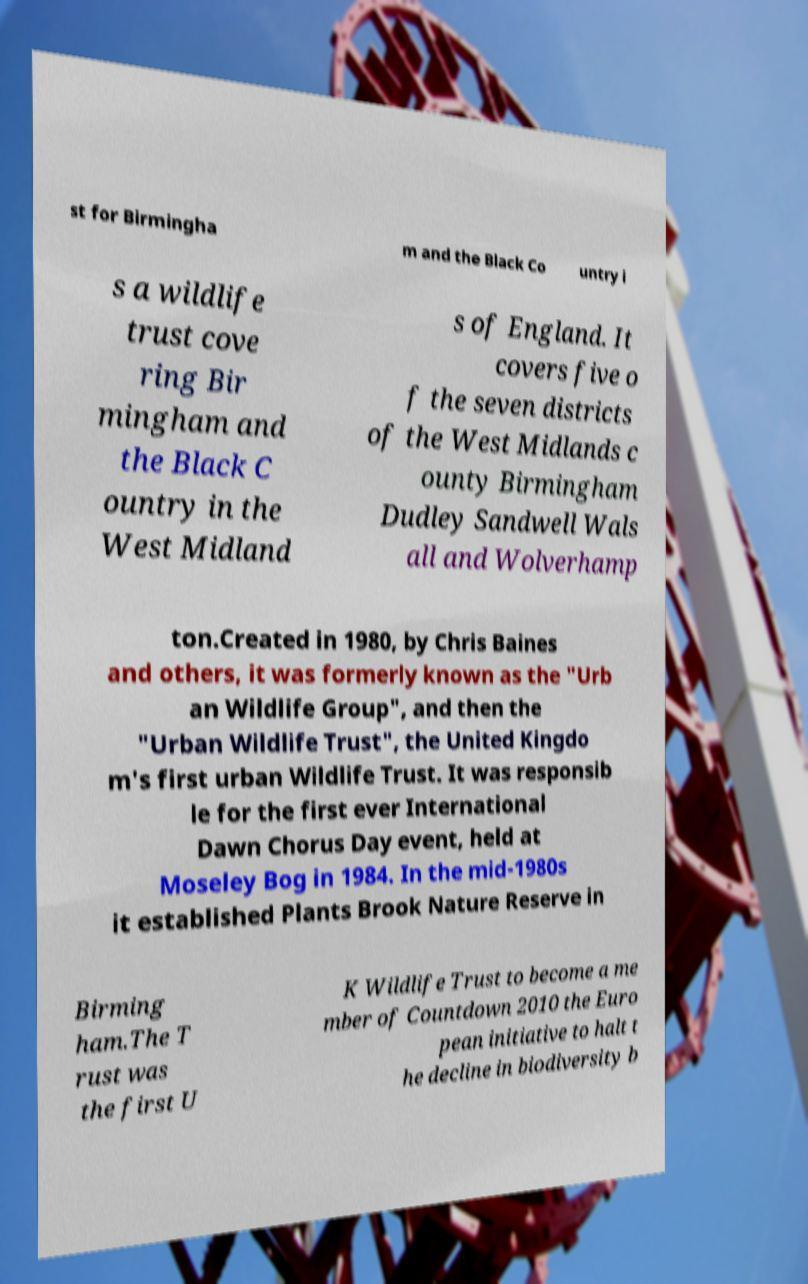Could you extract and type out the text from this image? st for Birmingha m and the Black Co untry i s a wildlife trust cove ring Bir mingham and the Black C ountry in the West Midland s of England. It covers five o f the seven districts of the West Midlands c ounty Birmingham Dudley Sandwell Wals all and Wolverhamp ton.Created in 1980, by Chris Baines and others, it was formerly known as the "Urb an Wildlife Group", and then the "Urban Wildlife Trust", the United Kingdo m's first urban Wildlife Trust. It was responsib le for the first ever International Dawn Chorus Day event, held at Moseley Bog in 1984. In the mid-1980s it established Plants Brook Nature Reserve in Birming ham.The T rust was the first U K Wildlife Trust to become a me mber of Countdown 2010 the Euro pean initiative to halt t he decline in biodiversity b 